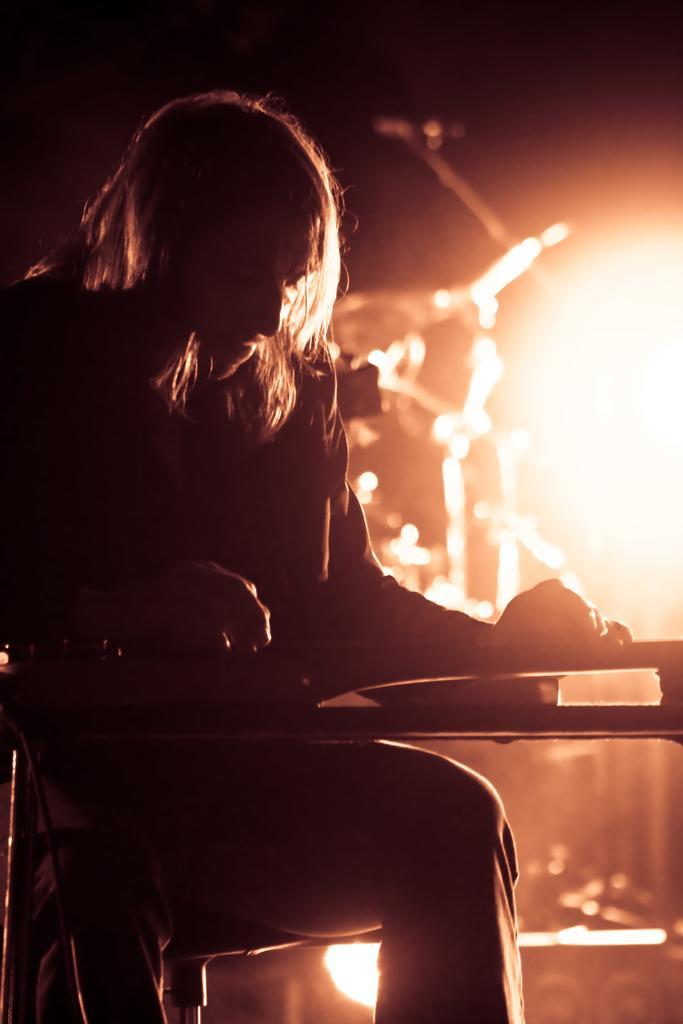What is the main subject in the foreground of the image? There is a person sitting in the foreground of the image. What object is in front of the person? There is a piano in front of the person. Can you describe the lighting in the image? There is light visible in the image. What musical instrument can be seen in the background of the image? There is a drum set in the background of the image. What color of paint is being used by the person to change the appearance of the drum set? There is no paint or indication of the person changing the appearance of the drum set in the image. 